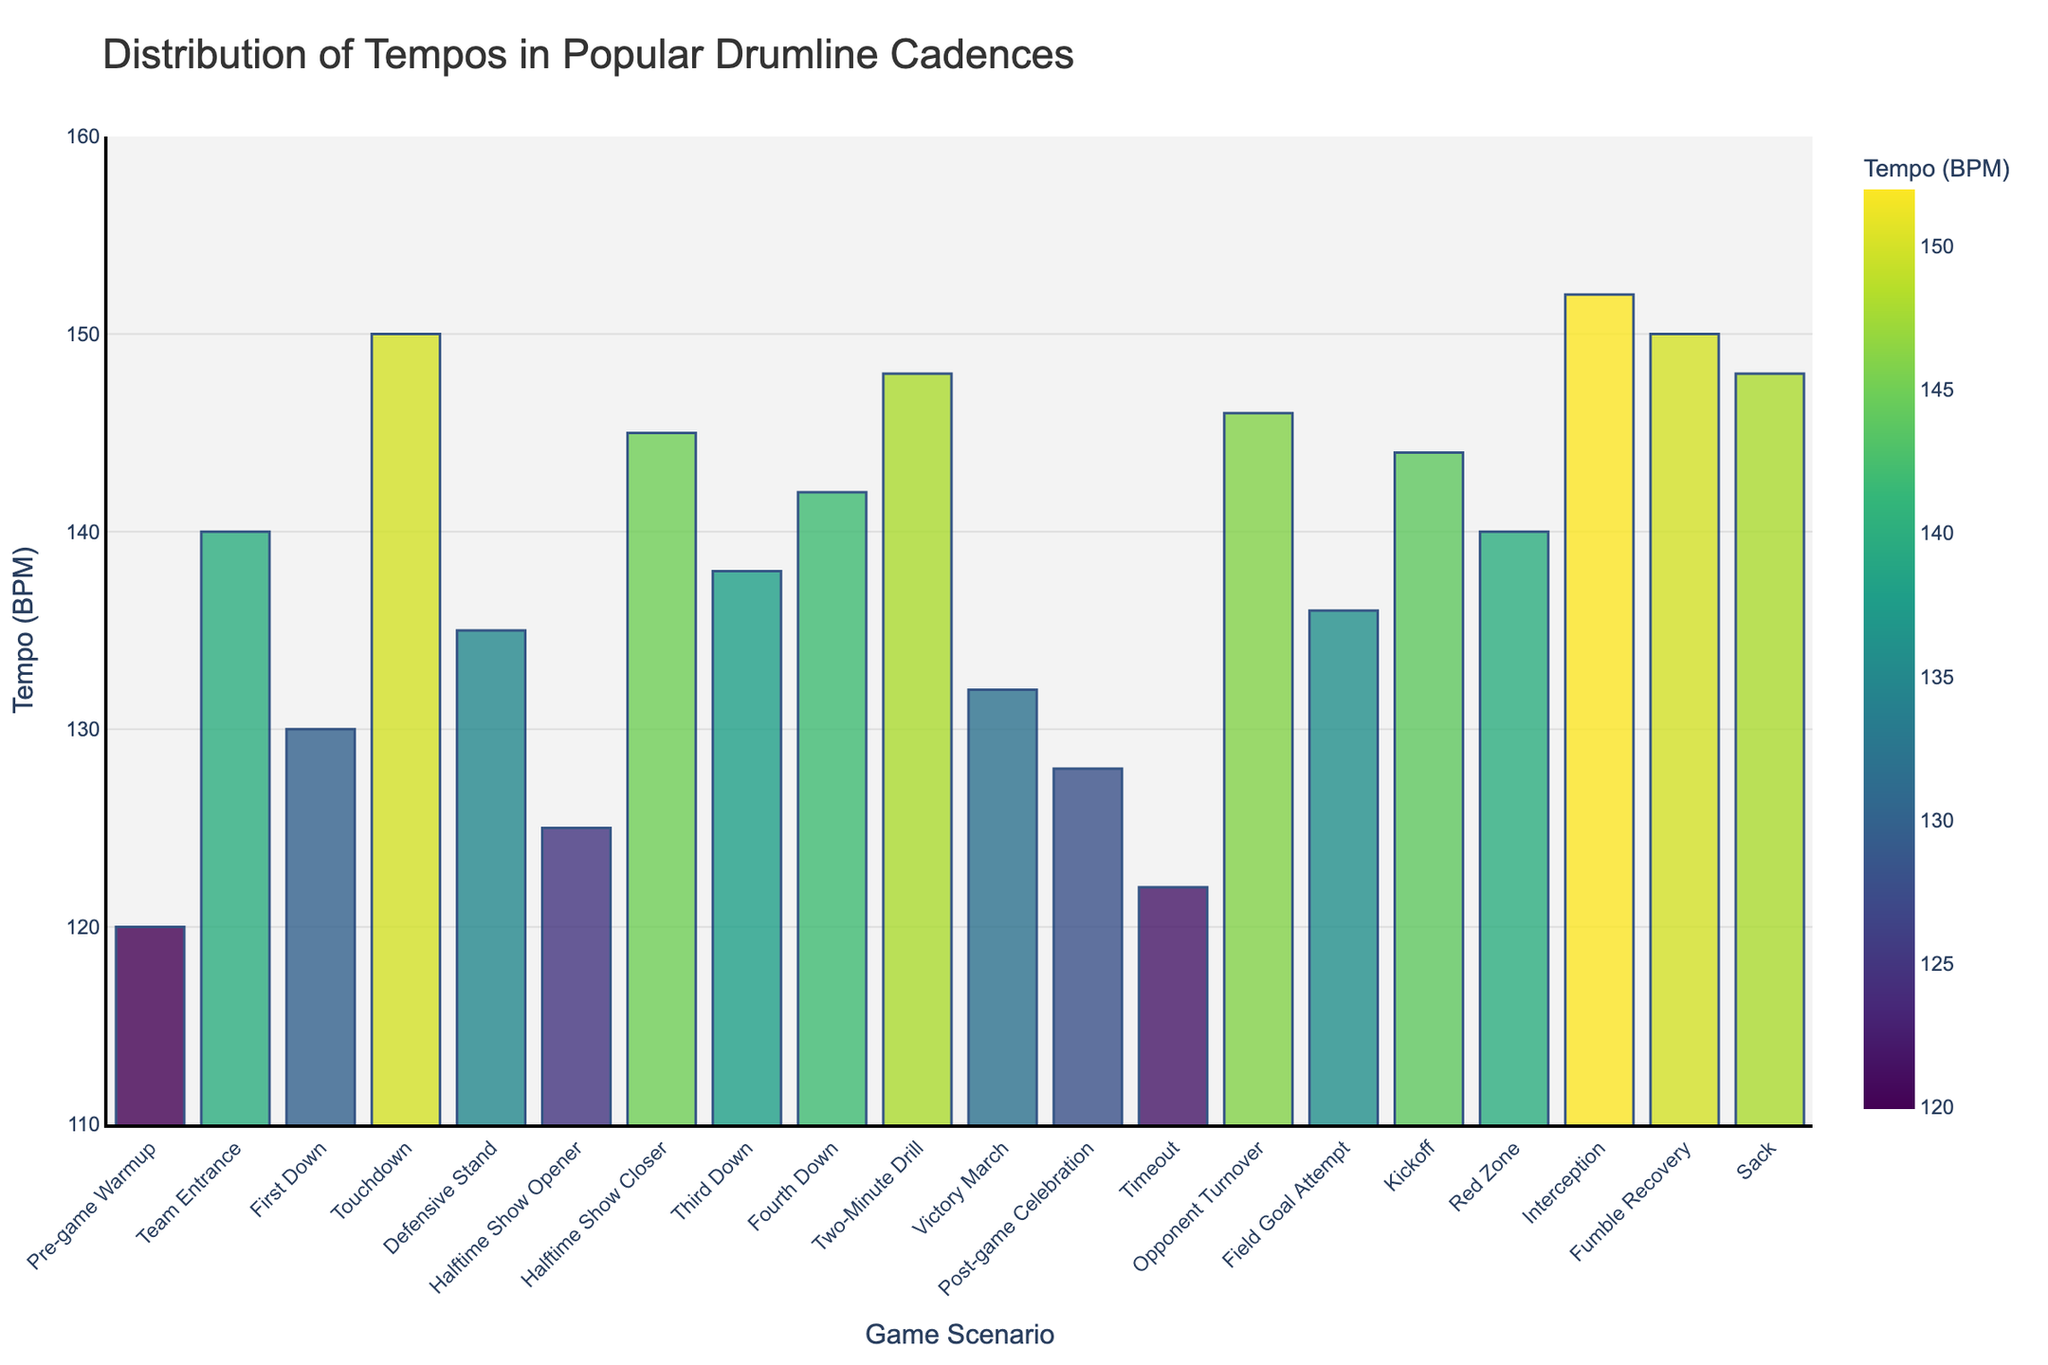Which game scenario has the highest tempo? By examining the height of the bars in the figure, we can see that the "Interception" scenario has the tallest bar, indicating the highest tempo.
Answer: Interception Which game scenario has the lowest tempo? The shortest bar in the figure corresponds to the "Pre-game Warmup" scenario, indicating the lowest tempo.
Answer: Pre-game Warmup How much higher is the tempo for "Touchdown" compared to "Pre-game Warmup"? The tempo for "Touchdown" is 150 BPM, and the tempo for "Pre-game Warmup" is 120 BPM. Subtracting these gives 150 - 120 = 30 BPM.
Answer: 30 BPM What is the average tempo of "First Down," "Touchdown," and "Defensive Stand"? The tempos for "First Down," "Touchdown," and "Defensive Stand" are 130, 150, and 135 BPM, respectively. Adding them gives 130 + 150 + 135 = 415 BPM. Dividing by 3 gives 415/3 ≈ 138.33 BPM.
Answer: 138.33 BPM Which has a higher tempo: "Third Down" or "Fourth Down"? By comparing the heights of the bars, "Fourth Down" has a taller bar than "Third Down," indicating a higher tempo.
Answer: Fourth Down Which game scenario has a tempo closest to the median tempo for all scenarios? To find the median tempo, we first arrange all tempos: 120, 122, 125, 128, 130, 132, 135, 136, 138, 140, 140, 142, 144, 145, 146, 148, 148, 150, 150, 152. The median is the average of the 10th and 11th values: (140 + 140)/2 = 140 BPM. The scenarios with a 140 BPM tempo are "Team Entrance" and "Red Zone."
Answer: Team Entrance, Red Zone What is the difference in tempo between the "Kickoff" and "Post-game Celebration" scenarios? The tempo for "Kickoff" is 144 BPM, and the tempo for "Post-game Celebration" is 128 BPM. Subtracting these gives 144 - 128 = 16 BPM.
Answer: 16 BPM What range of tempos is shown in the figure? The lowest tempo is 120 BPM (Pre-game Warmup) and the highest tempo is 152 BPM (Interception). The range is the difference between these two values: 152 - 120 = 32 BPM.
Answer: 32 BPM How does the tempo for "Defensive Stand" compare with the average tempo for all scenarios? First, we calculate the average tempo for all scenarios: sum of all tempos = 120+140+130+150+135+125+145+138+142+148+132+128+122+146+136+144+140+152+150+148 = 2801. There are 20 scenarios, so the average is 2801/20 = 140.05 BPM. The tempo for "Defensive Stand" is 135 BPM, which is slightly below the average of 140.05 BPM.
Answer: Below Average (135 BPM vs. 140.05 BPM) What game scenarios have tempos within 5 BPM of each other? To find scenarios within 5 BPM, we look for bars with close heights. Pairs include "Third Down" (138 BPM) & "Fourth Down" (142 BPM), "First Down" (130 BPM) & "Victory March" (132 BPM), "Timeout" (122 BPM) & "Pre-game Warmup" (120 BPM), and others like "Kickoff" (144 BPM) & "Two-Minute Drill" (148 BPM).
Answer: Multiple pairs 